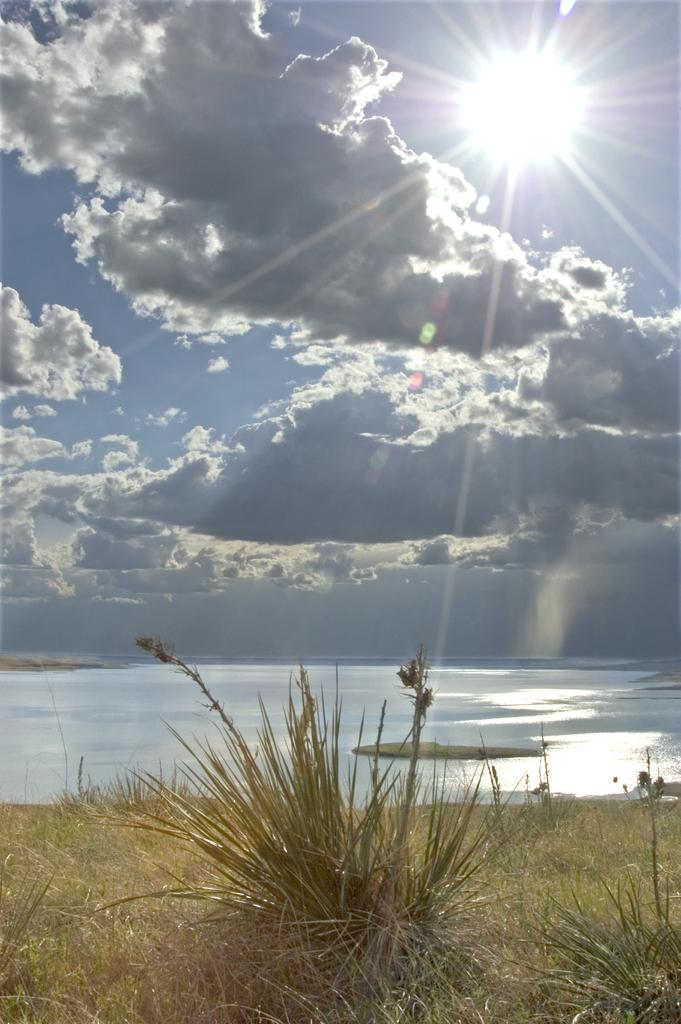What type of vegetation is present at the bottom of the image? There is grass and plants at the bottom of the image. What natural feature can be seen in the background of the image? There is a river in the background of the image. What is visible at the top of the image? The sky is visible at the top of the image. Can the sun be seen in the sky? Yes, the sun is observable in the sky. What is the rate at which the bells are ringing in the image? There are no bells present in the image, so it is not possible to determine their ringing rate. Can you tell me the heart rate of the plants in the image? Plants do not have a heart rate, so this information cannot be determined from the image. 